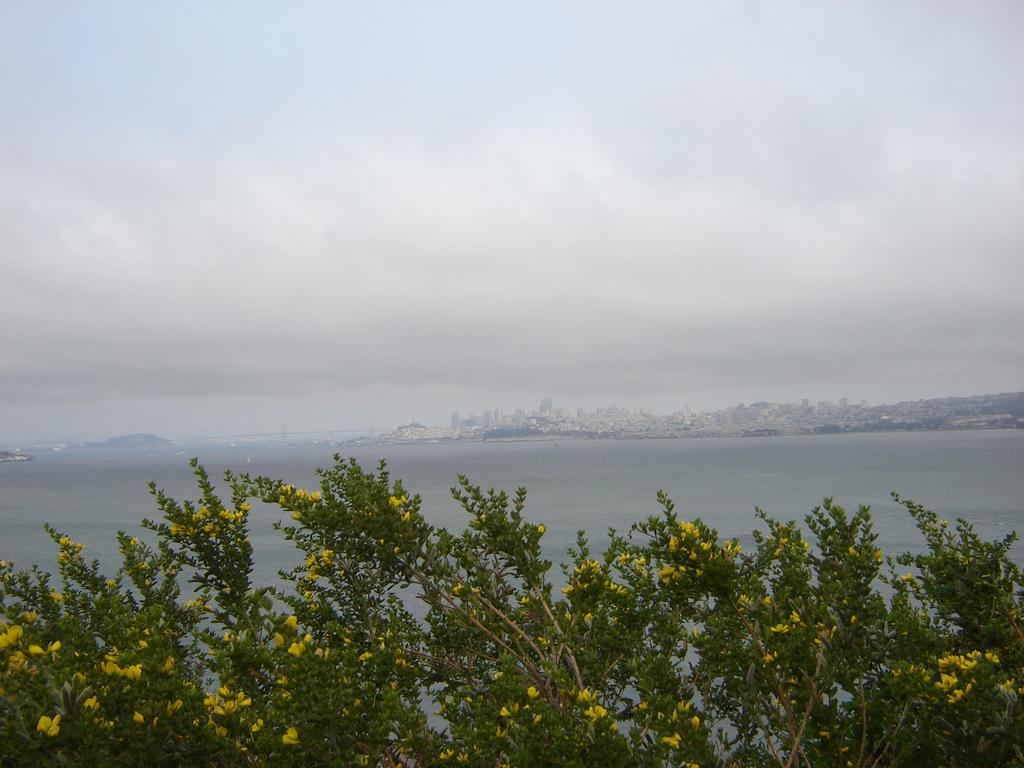What type of vegetation is present in the image? There are trees with flowers in the image. What type of structures can be seen in the image? There are buildings in the image. What natural element is visible in the image? There is water visible in the image. What geographical feature is present in the image? There are mountains in the image. What can be seen in the background of the image? The sky with clouds is visible in the background of the image. What type of prose is being recited by the trees in the image? There is no indication in the image that the trees are reciting any prose. How many feet are visible in the image? There are no feet visible in the image; it features trees, buildings, water, mountains, and a sky with clouds. 